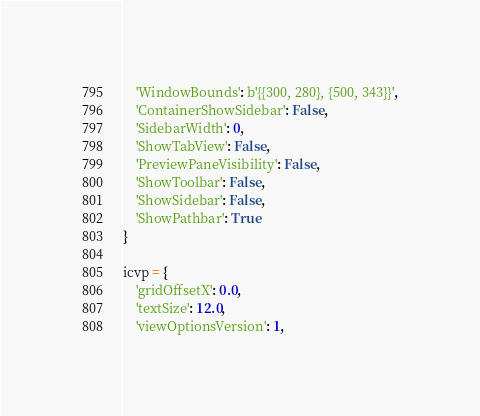<code> <loc_0><loc_0><loc_500><loc_500><_Python_>    'WindowBounds': b'{{300, 280}, {500, 343}}',
    'ContainerShowSidebar': False,
    'SidebarWidth': 0,
    'ShowTabView': False,
    'PreviewPaneVisibility': False,
    'ShowToolbar': False,
    'ShowSidebar': False,
    'ShowPathbar': True
}

icvp = {
    'gridOffsetX': 0.0,
    'textSize': 12.0,
    'viewOptionsVersion': 1,</code> 